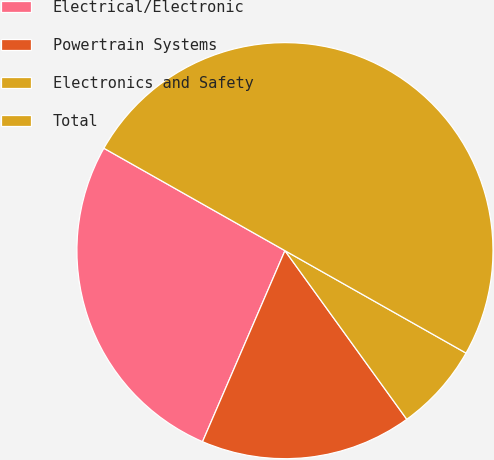Convert chart. <chart><loc_0><loc_0><loc_500><loc_500><pie_chart><fcel>Electrical/Electronic<fcel>Powertrain Systems<fcel>Electronics and Safety<fcel>Total<nl><fcel>26.71%<fcel>16.44%<fcel>6.85%<fcel>50.0%<nl></chart> 